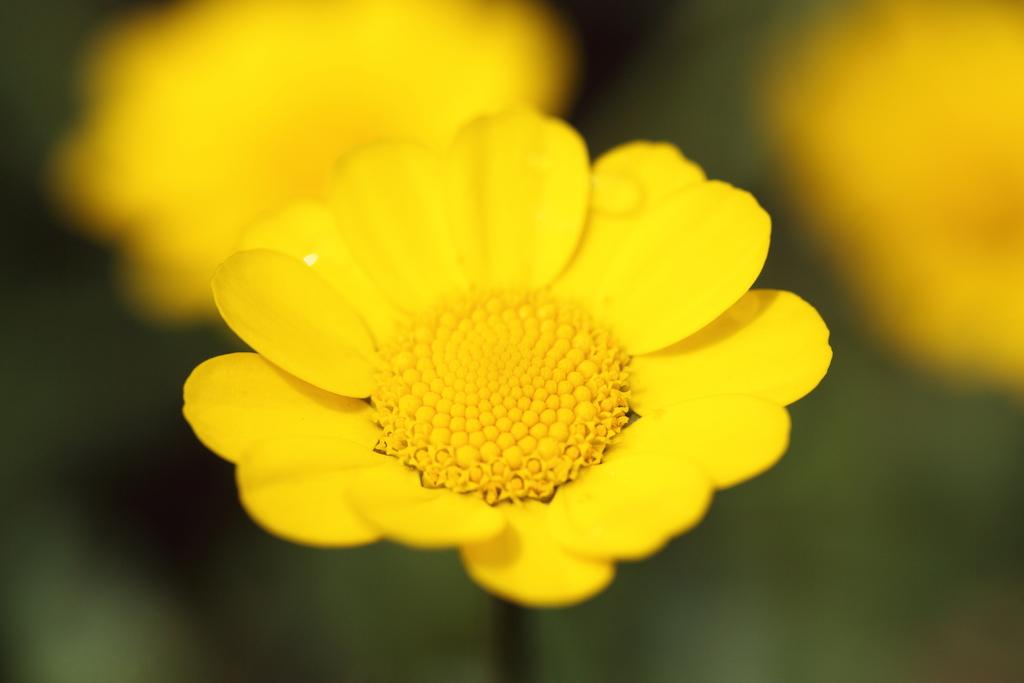What is present in the image? There are flowers in the image. Can you describe the background of the image? The background of the image is blurry. What country is depicted in the image? There is no country depicted in the image; it features flowers and a blurry background. Can you see a net in the image? There is no net present in the image. 